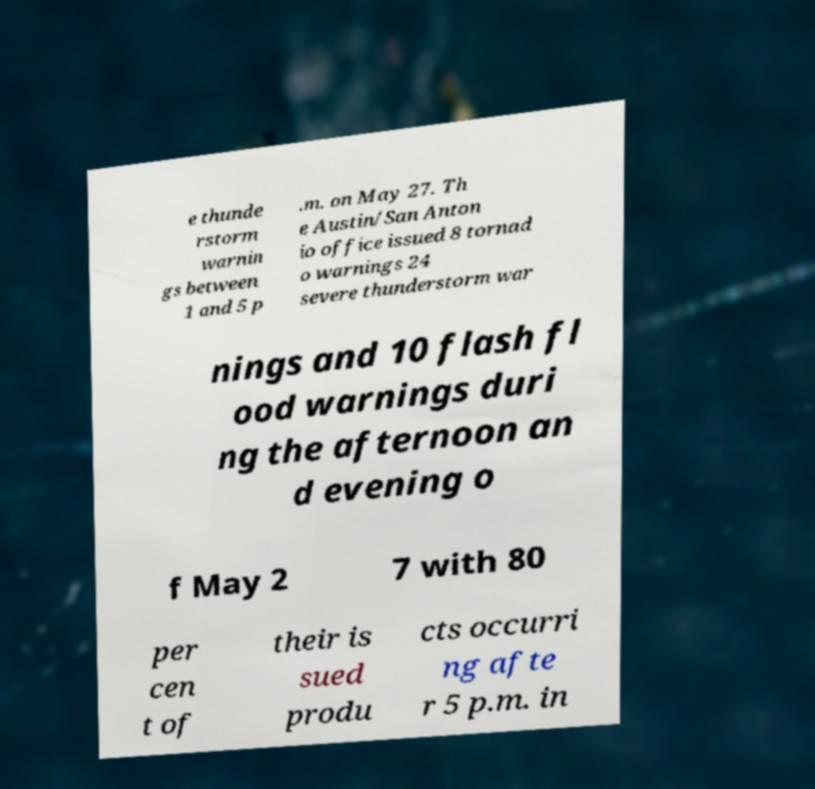Could you extract and type out the text from this image? e thunde rstorm warnin gs between 1 and 5 p .m. on May 27. Th e Austin/San Anton io office issued 8 tornad o warnings 24 severe thunderstorm war nings and 10 flash fl ood warnings duri ng the afternoon an d evening o f May 2 7 with 80 per cen t of their is sued produ cts occurri ng afte r 5 p.m. in 